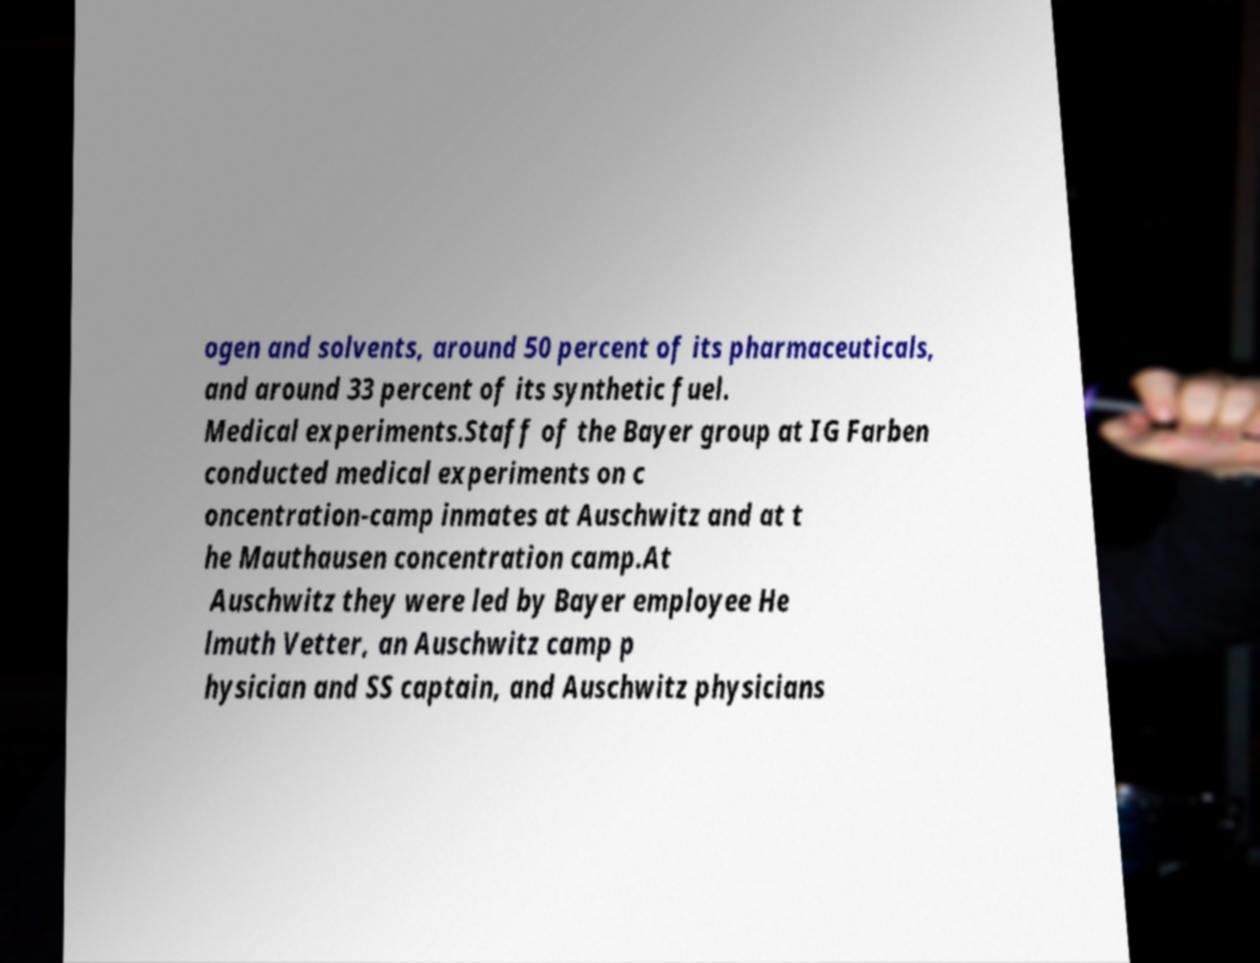I need the written content from this picture converted into text. Can you do that? ogen and solvents, around 50 percent of its pharmaceuticals, and around 33 percent of its synthetic fuel. Medical experiments.Staff of the Bayer group at IG Farben conducted medical experiments on c oncentration-camp inmates at Auschwitz and at t he Mauthausen concentration camp.At Auschwitz they were led by Bayer employee He lmuth Vetter, an Auschwitz camp p hysician and SS captain, and Auschwitz physicians 